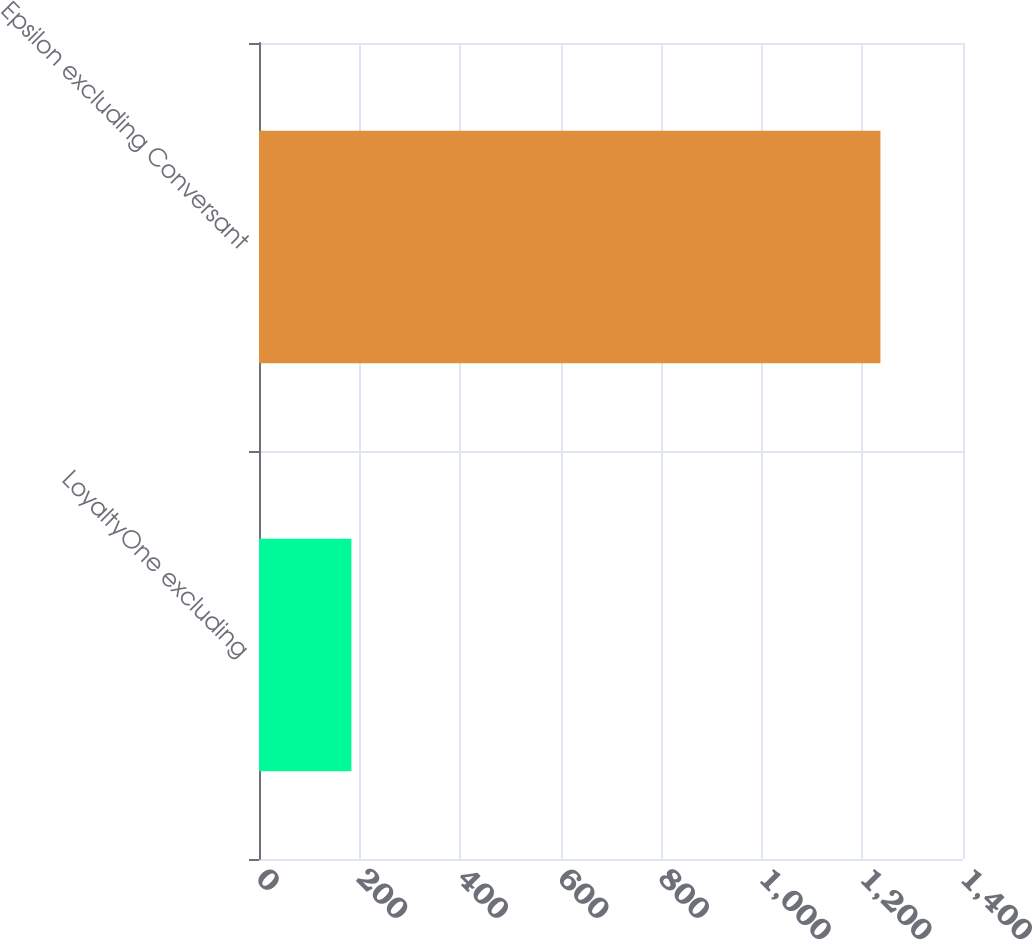<chart> <loc_0><loc_0><loc_500><loc_500><bar_chart><fcel>LoyaltyOne excluding<fcel>Epsilon excluding Conversant<nl><fcel>183.7<fcel>1235.8<nl></chart> 